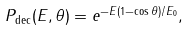<formula> <loc_0><loc_0><loc_500><loc_500>P _ { \text {dec} } ( E , \theta ) = e ^ { - E ( 1 - \cos \theta ) / E _ { 0 } } ,</formula> 